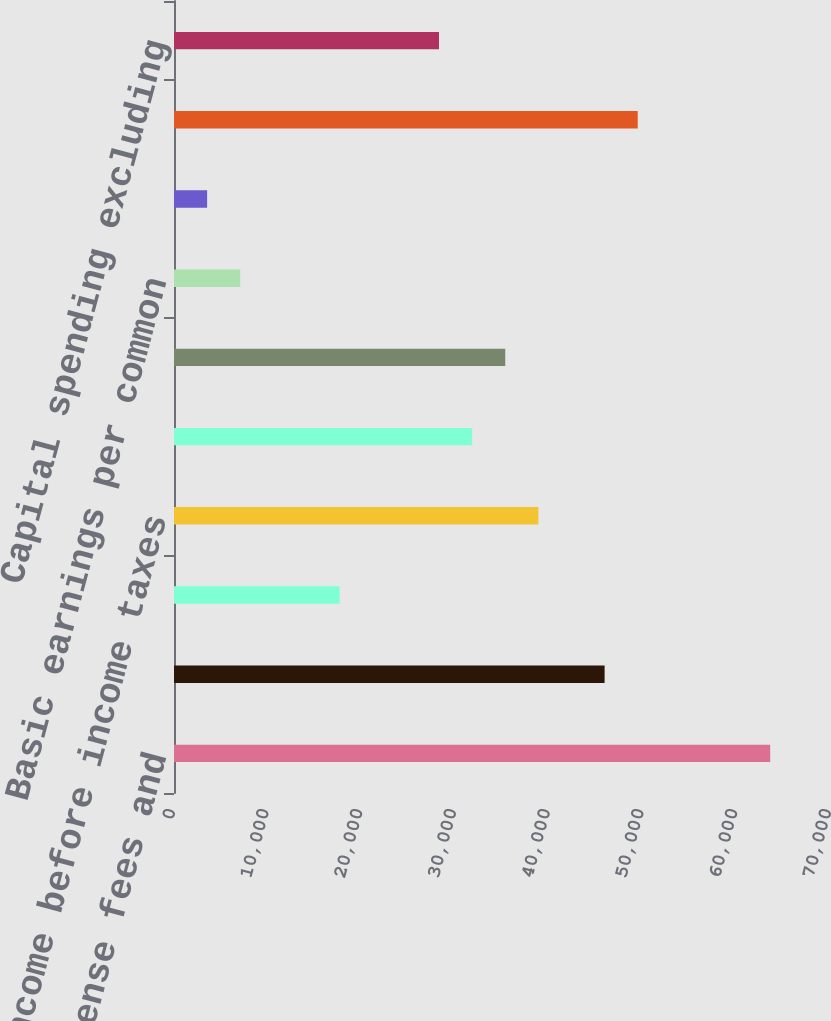Convert chart to OTSL. <chart><loc_0><loc_0><loc_500><loc_500><bar_chart><fcel>Franchise and license fees and<fcel>Operating Profit^(c)<fcel>Interest expense net<fcel>Income before income taxes<fcel>Net Income - including<fcel>Net Income - YUM! Brands Inc<fcel>Basic earnings per common<fcel>Diluted earnings per common<fcel>Cash Flow Data Provided by<fcel>Capital spending excluding<nl><fcel>63620.7<fcel>45948.4<fcel>17672.7<fcel>38879.5<fcel>31810.6<fcel>35345<fcel>7069.36<fcel>3534.91<fcel>49482.9<fcel>28276.1<nl></chart> 